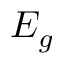Convert formula to latex. <formula><loc_0><loc_0><loc_500><loc_500>E _ { g }</formula> 